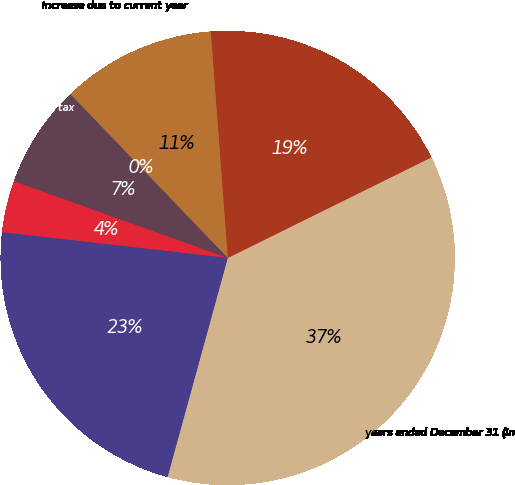Convert chart to OTSL. <chart><loc_0><loc_0><loc_500><loc_500><pie_chart><fcel>years ended December 31 (in<fcel>January 1<fcel>Increase due to current year<fcel>Increase due to prior year tax<fcel>Decrease due to prior year tax<fcel>Settlements<fcel>December 31<nl><fcel>36.57%<fcel>18.89%<fcel>10.98%<fcel>0.02%<fcel>7.33%<fcel>3.67%<fcel>22.54%<nl></chart> 